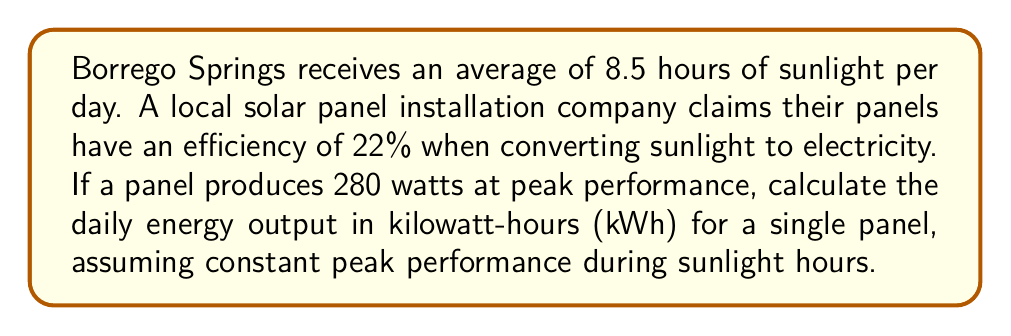Show me your answer to this math problem. Let's approach this step-by-step:

1) First, we need to convert the panel's peak power from watts to kilowatts:
   $280 \text{ watts} = 0.28 \text{ kilowatts}$

2) Now, we have the following information:
   - Peak power: $0.28 \text{ kW}$
   - Efficiency: $22\% = 0.22$
   - Sunlight hours per day: $8.5 \text{ hours}$

3) The energy output is calculated by multiplying power by time:
   $\text{Energy} = \text{Power} \times \text{Time}$

4) However, we need to account for the efficiency of the panel:
   $\text{Actual Energy} = \text{Peak Power} \times \text{Efficiency} \times \text{Time}$

5) Plugging in our values:
   $$\text{Energy Output} = 0.28 \text{ kW} \times 0.22 \times 8.5 \text{ hours}$$

6) Calculating:
   $$\text{Energy Output} = 0.5236 \text{ kWh}$$

7) Rounding to two decimal places:
   $$\text{Energy Output} \approx 0.52 \text{ kWh}$$
Answer: $0.52 \text{ kWh}$ 